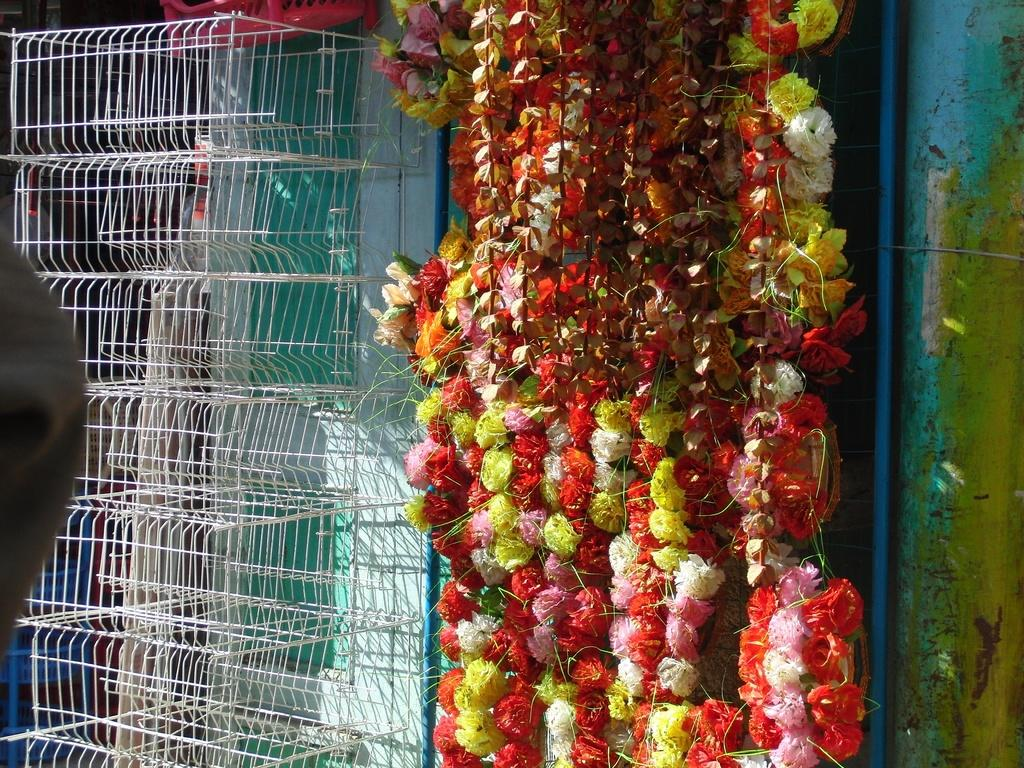What structures are present in the image? There are cages in the image. What can be seen in the middle of the image? There are flowers in the middle of the image. What type of car is parked near the cages in the image? There is no car present in the image; it only features cages and flowers. How many accounts are associated with the zoo in the image? There is no mention of a zoo or any accounts in the image. 